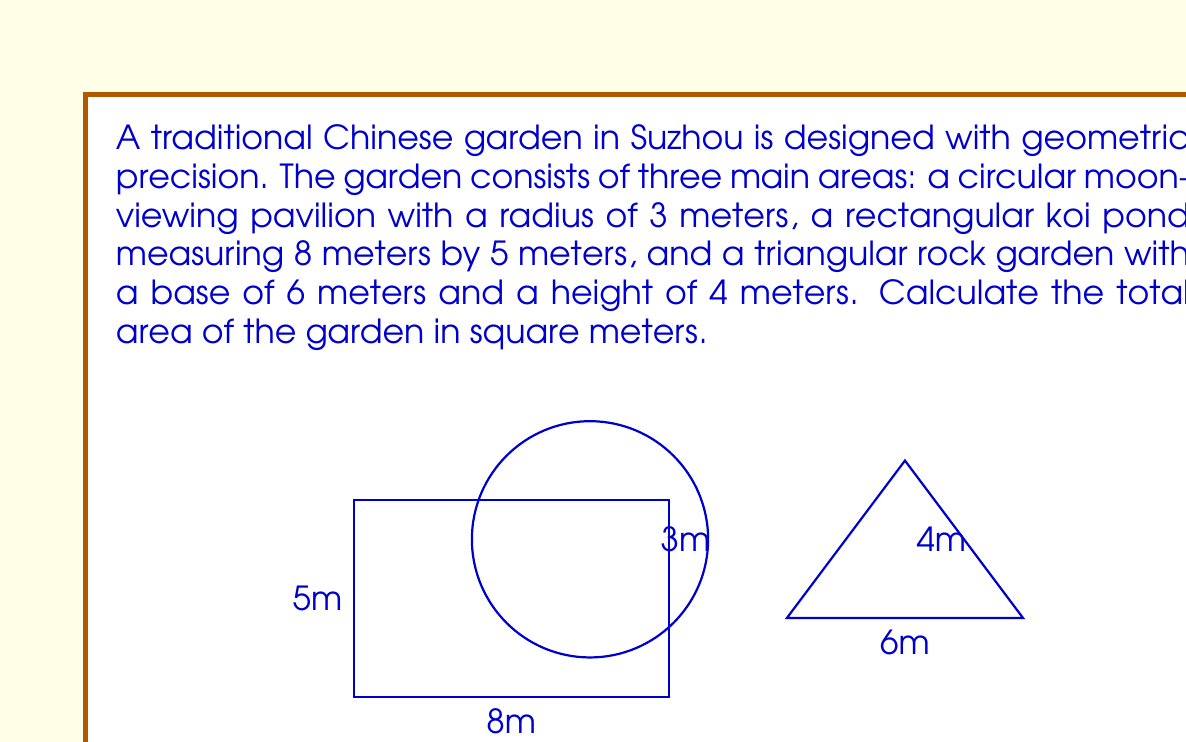Could you help me with this problem? To calculate the total area of the garden, we need to sum the areas of the three geometric shapes:

1. Circular moon-viewing pavilion:
   Area of a circle = $\pi r^2$
   $A_circle = \pi \cdot 3^2 = 9\pi$ square meters

2. Rectangular koi pond:
   Area of a rectangle = length $\times$ width
   $A_rectangle = 8 \cdot 5 = 40$ square meters

3. Triangular rock garden:
   Area of a triangle = $\frac{1}{2} \cdot$ base $\cdot$ height
   $A_triangle = \frac{1}{2} \cdot 6 \cdot 4 = 12$ square meters

Total area of the garden:
$$A_{total} = A_{circle} + A_{rectangle} + A_{triangle}$$
$$A_{total} = 9\pi + 40 + 12$$
$$A_{total} = 9\pi + 52$$

To simplify:
$$A_{total} \approx 28.27 + 52 = 80.27$$ square meters (rounded to two decimal places)
Answer: $9\pi + 52$ sq m $\approx 80.27$ sq m 